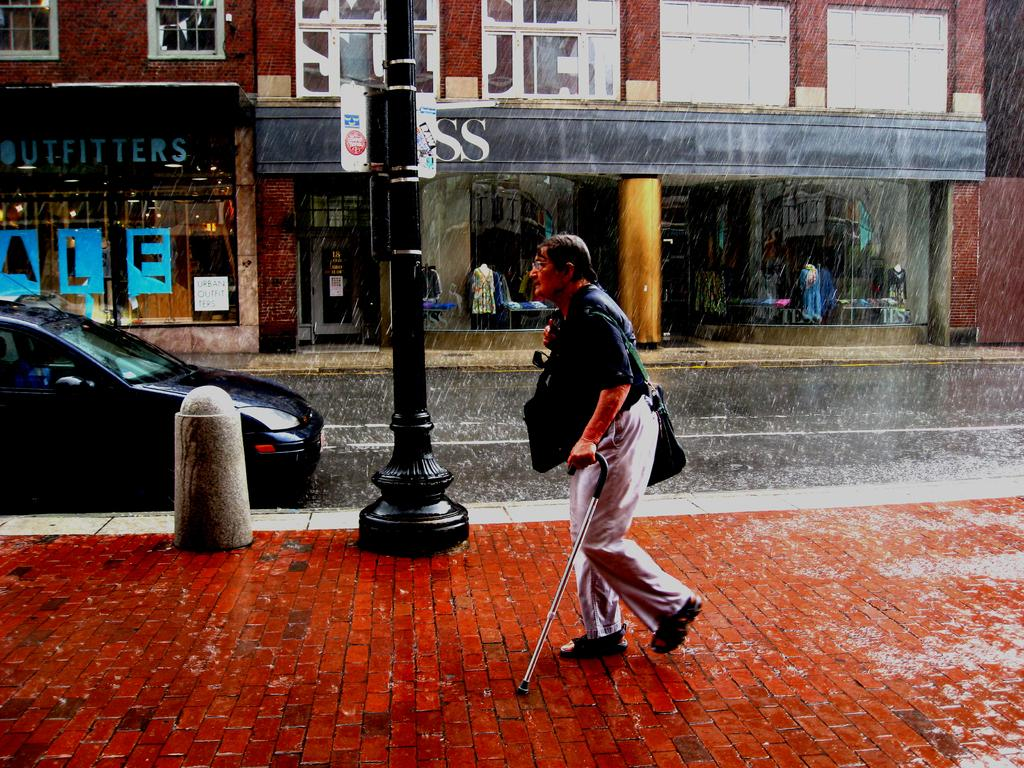What is the person in the image doing? The person in the image is walking. Where is the person walking? The person is walking on a footpath. What is the person holding while walking? The person is holding a stick. What else can be seen on the road in the image? There is a vehicle on the road. What type of structures are visible in the image? There are buildings visible in the image. How many people are present in the image? There are people present in the image. What is the tall, vertical object in the image? There is a pole in the image. Can you describe the unspecified objects in the image? Unfortunately, the facts provided do not give any details about the unspecified objects, so we cannot describe them. What position does the person hold in the company they work for, as seen in the image? The facts provided do not give any information about the person's job or company, so we cannot determine their position from the image. 